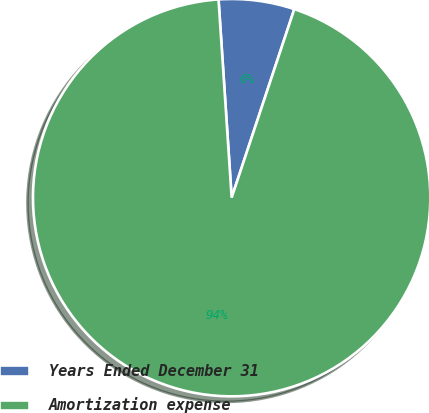<chart> <loc_0><loc_0><loc_500><loc_500><pie_chart><fcel>Years Ended December 31<fcel>Amortization expense<nl><fcel>6.16%<fcel>93.84%<nl></chart> 